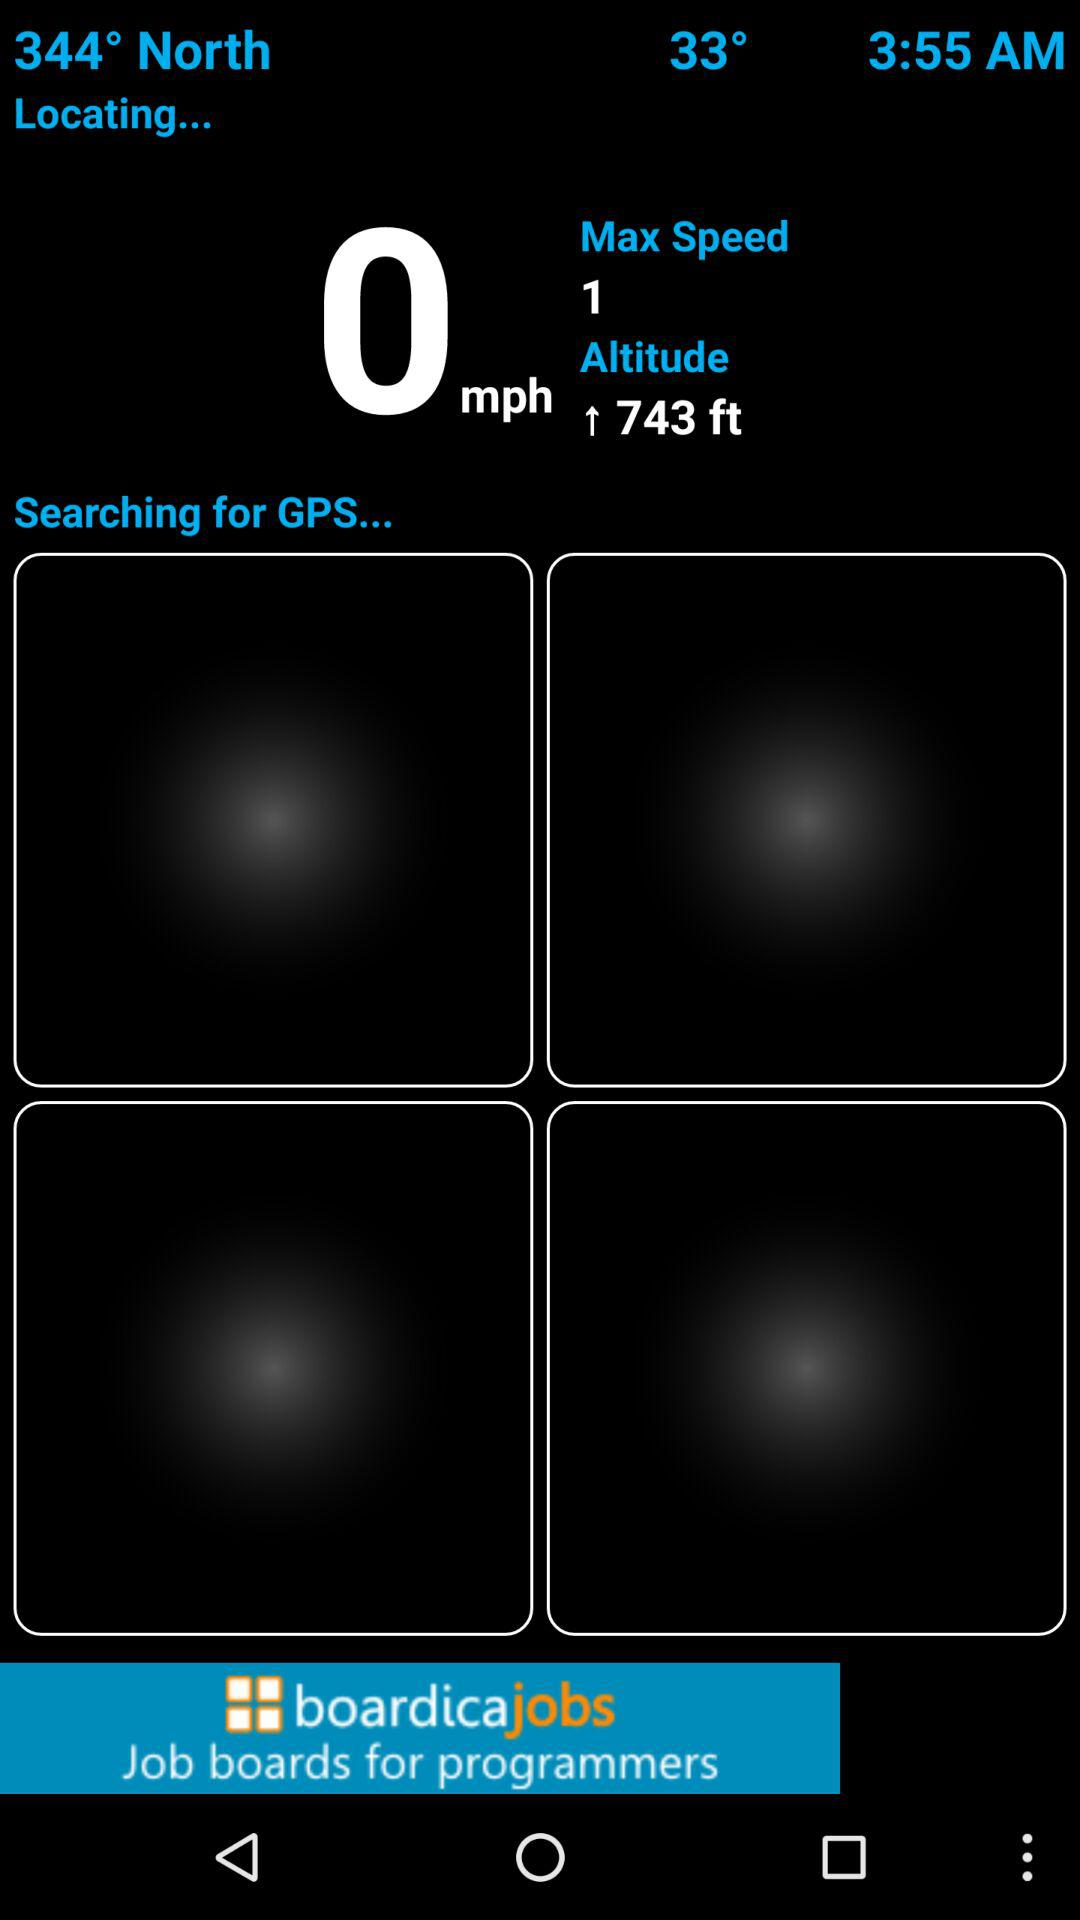What is the shown temperature? The shown temperature is 33°. 